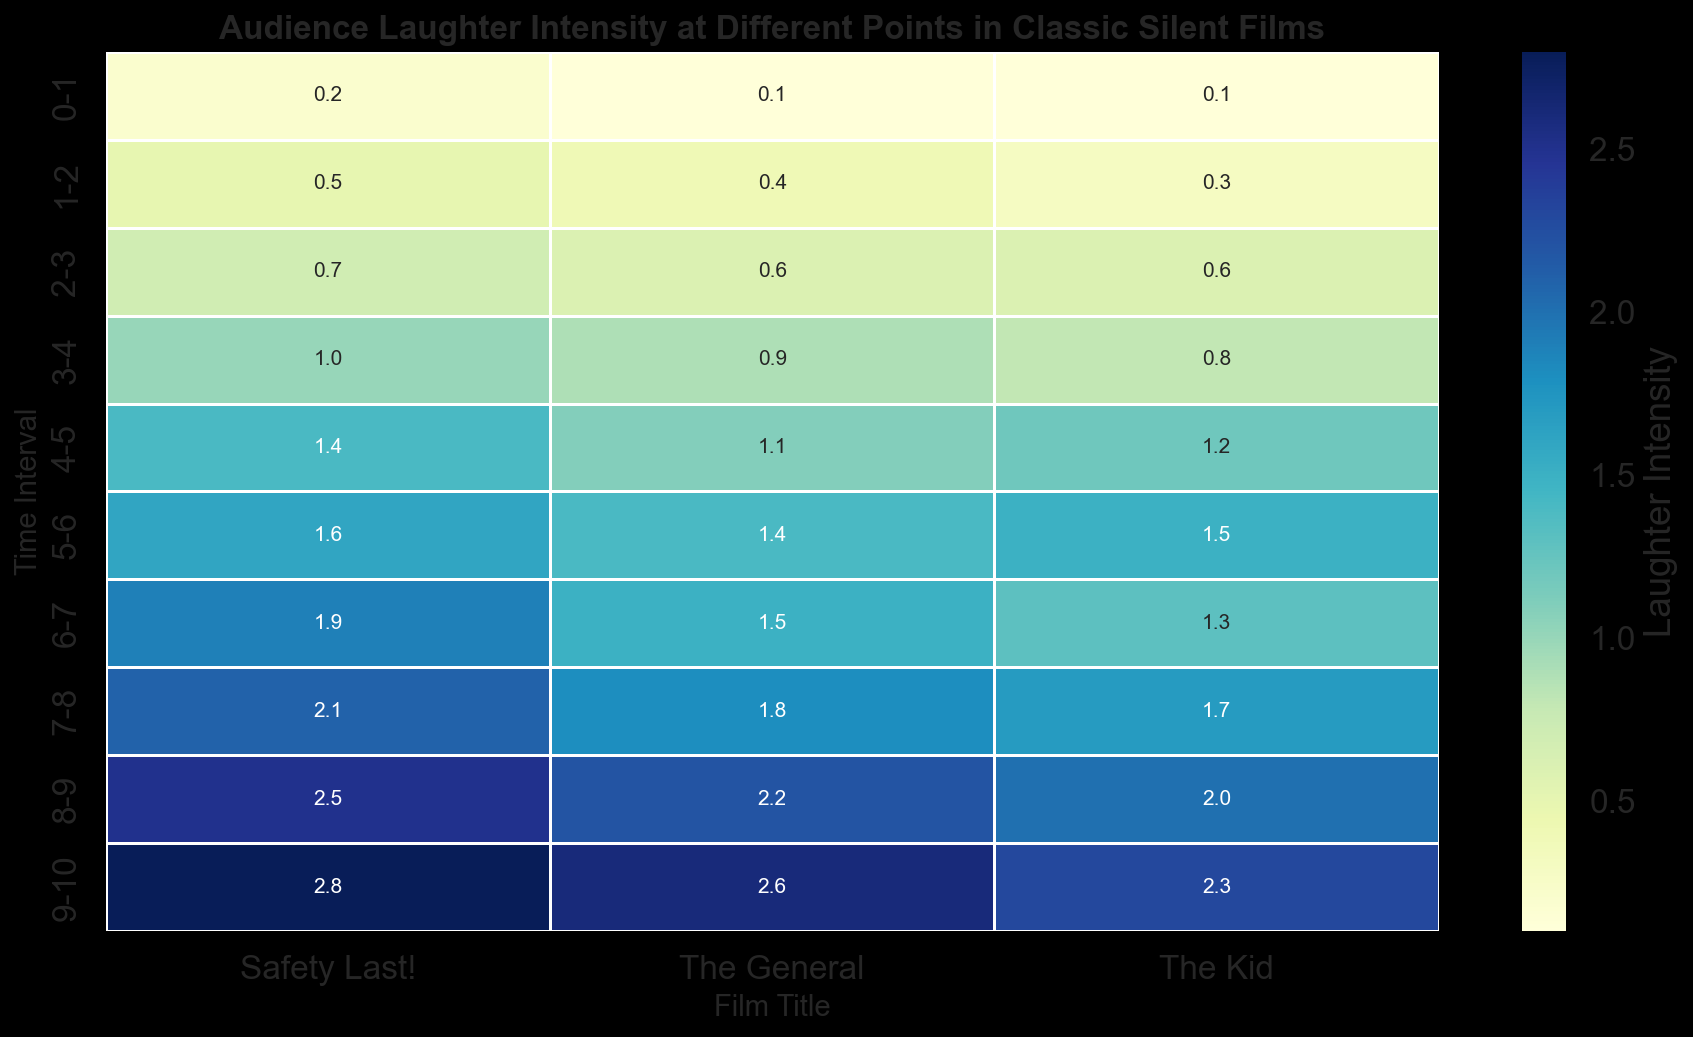What is the highest laughter intensity recorded for 'The Kid'? Looking at the heatmap under the column for 'The Kid', the highest value shown is 2.3 during the 9-10 time interval.
Answer: 2.3 How does the laughter intensity at 5-6 time interval compare between 'The General' and 'Safety Last!'? At the 5-6 interval, 'The General' has a laughter intensity of 1.4 and 'Safety Last!' has 1.6, so 'Safety Last!' is higher.
Answer: Safety Last! is higher Which film has the most consistent laughter intensity increase across all time intervals? By visually comparing the progression of laughter intensity values for each film across the intervals, 'Safety Last!' shows a steadily increasing pattern without large fluctuations.
Answer: Safety Last! What is the average laughter intensity for 'The Kid' between 0-5 time intervals? Summing up the intensities from 0-5 (0.1 + 0.3 + 0.6 + 0.8 + 1.2) equals 3.0. The average is 3.0/5 = 0.6.
Answer: 0.6 During which time interval does 'The General' have the lowest laughter intensity? The lowest laughter intensity for 'The General' can be observed in the 0-1 time interval, where the value is 0.1.
Answer: 0-1 Which film exhibits a sharper increase in laughter intensity from 2-3 to 3-4, 'The Kid' or 'The General'? For 'The Kid', it increases from 0.6 to 0.8 (difference of 0.2). For 'The General', it increases from 0.6 to 0.9 (difference of 0.3). Therefore, 'The General' has a sharper increase.
Answer: The General What is the total laughter intensity recorded for 'Safety Last!' across all time intervals? Summing up all laughter intensity values for 'Safety Last!' (0.2 + 0.5 + 0.7 + 1.0 + 1.4 + 1.6 + 1.9 + 2.1 + 2.5 + 2.8) equals 14.7.
Answer: 14.7 Which film had the highest laughter intensity in the 8-9 interval, and what was the value? Checking the values for each film at the 8-9 interval: 'The Kid' (2.0), 'Safety Last!' (2.5), and 'The General' (2.2). 'Safety Last!' has the highest value of 2.5.
Answer: Safety Last!, 2.5 By how much does the laughter intensity increase in 'The Kid' from 1-2 to 4-5? 'The Kid' increases from 0.3 (1-2) to 1.2 (4-5), so the increase is 1.2 - 0.3 = 0.9.
Answer: 0.9 